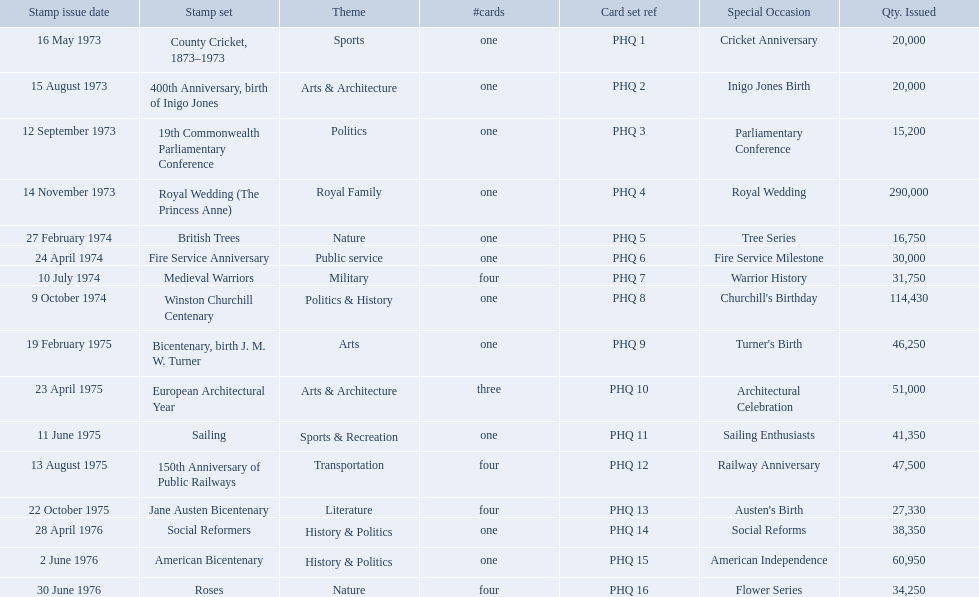Which stamp sets were issued? County Cricket, 1873–1973, 400th Anniversary, birth of Inigo Jones, 19th Commonwealth Parliamentary Conference, Royal Wedding (The Princess Anne), British Trees, Fire Service Anniversary, Medieval Warriors, Winston Churchill Centenary, Bicentenary, birth J. M. W. Turner, European Architectural Year, Sailing, 150th Anniversary of Public Railways, Jane Austen Bicentenary, Social Reformers, American Bicentenary, Roses. Of those stamp sets, which had more that 200,000 issued? Royal Wedding (The Princess Anne). What are all the stamp sets? County Cricket, 1873–1973, 400th Anniversary, birth of Inigo Jones, 19th Commonwealth Parliamentary Conference, Royal Wedding (The Princess Anne), British Trees, Fire Service Anniversary, Medieval Warriors, Winston Churchill Centenary, Bicentenary, birth J. M. W. Turner, European Architectural Year, Sailing, 150th Anniversary of Public Railways, Jane Austen Bicentenary, Social Reformers, American Bicentenary, Roses. For these sets, what were the quantities issued? 20,000, 20,000, 15,200, 290,000, 16,750, 30,000, 31,750, 114,430, 46,250, 51,000, 41,350, 47,500, 27,330, 38,350, 60,950, 34,250. Of these, which quantity is above 200,000? 290,000. What is the stamp set corresponding to this quantity? Royal Wedding (The Princess Anne). Which are the stamp sets in the phq? County Cricket, 1873–1973, 400th Anniversary, birth of Inigo Jones, 19th Commonwealth Parliamentary Conference, Royal Wedding (The Princess Anne), British Trees, Fire Service Anniversary, Medieval Warriors, Winston Churchill Centenary, Bicentenary, birth J. M. W. Turner, European Architectural Year, Sailing, 150th Anniversary of Public Railways, Jane Austen Bicentenary, Social Reformers, American Bicentenary, Roses. Which stamp sets have higher than 200,000 quantity issued? Royal Wedding (The Princess Anne). What are all of the stamp sets? County Cricket, 1873–1973, 400th Anniversary, birth of Inigo Jones, 19th Commonwealth Parliamentary Conference, Royal Wedding (The Princess Anne), British Trees, Fire Service Anniversary, Medieval Warriors, Winston Churchill Centenary, Bicentenary, birth J. M. W. Turner, European Architectural Year, Sailing, 150th Anniversary of Public Railways, Jane Austen Bicentenary, Social Reformers, American Bicentenary, Roses. Which of these sets has three cards in it? European Architectural Year. Which stamp sets contained more than one card? Medieval Warriors, European Architectural Year, 150th Anniversary of Public Railways, Jane Austen Bicentenary, Roses. Of those stamp sets, which contains a unique number of cards? European Architectural Year. 